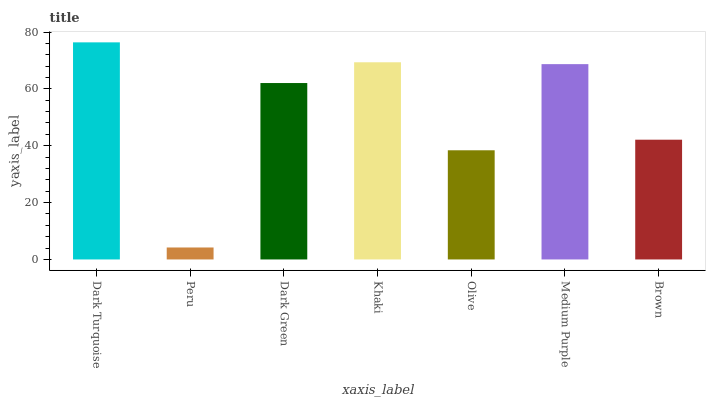Is Dark Green the minimum?
Answer yes or no. No. Is Dark Green the maximum?
Answer yes or no. No. Is Dark Green greater than Peru?
Answer yes or no. Yes. Is Peru less than Dark Green?
Answer yes or no. Yes. Is Peru greater than Dark Green?
Answer yes or no. No. Is Dark Green less than Peru?
Answer yes or no. No. Is Dark Green the high median?
Answer yes or no. Yes. Is Dark Green the low median?
Answer yes or no. Yes. Is Dark Turquoise the high median?
Answer yes or no. No. Is Olive the low median?
Answer yes or no. No. 